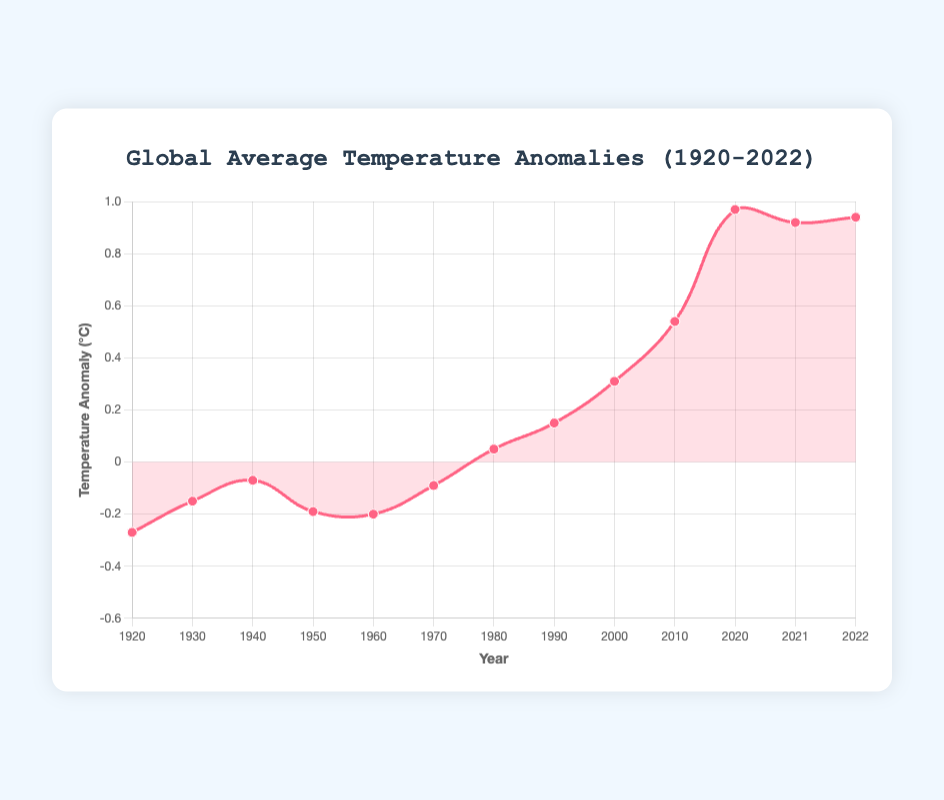What's the global average temperature anomaly in 2022? To find the anomaly for 2022, look at the value associated with that year on the chart.
Answer: 0.94°C How much did the global temperature anomaly increase from 1920 to 2020? Subtract the anomaly in 1920 from the anomaly in 2020: 0.97°C - (-0.27°C) = 0.97°C + 0.27°C = 1.24°C.
Answer: 1.24°C In which year did the temperature anomaly first become positive? Identify the first year in the chart with a temperature anomaly greater than 0°C, which is 1980 with a value of 0.05°C.
Answer: 1980 Which decade saw the highest increase in the global temperature anomaly? Compare the increase in anomalies for each decade: 2010 (0.54°C) to 2020 (0.97°C) has the largest increase: 0.97°C - 0.54°C = 0.43°C.
Answer: 2010s By how much did the global temperature anomaly change between 1990 and 2000? Find the difference in anomaly values between these years: 0.31°C (2000) - 0.15°C (1990) = 0.16°C.
Answer: 0.16°C Which color represents the global average temperature anomaly on the plot? The curve and the points on the plot are primarily shown in a red color.
Answer: Red During which decade did the global temperature anomaly decrease compared to the previous decade? Look for a decline in values from one decade to the next, from 1940 (-0.07°C) to 1950 (-0.19°C).
Answer: 1940s What is the median global temperature anomaly observed in the dataset? List anomalies in ascending order: -0.27, -0.20, -0.19, -0.15, -0.09, -0.07, 0.05, 0.15, 0.31, 0.54, 0.92, 0.94, 0.97. The median value in the ordered list is 0.05°C (which is the 7th value in this 13-value dataset).
Answer: 0.05°C What is the difference between the highest and lowest global temperature anomalies? Substract the lowest anomaly (-0.27°C) from the highest anomaly (0.97°C): 0.97°C - (-0.27°C) = 1.24°C.
Answer: 1.24°C 